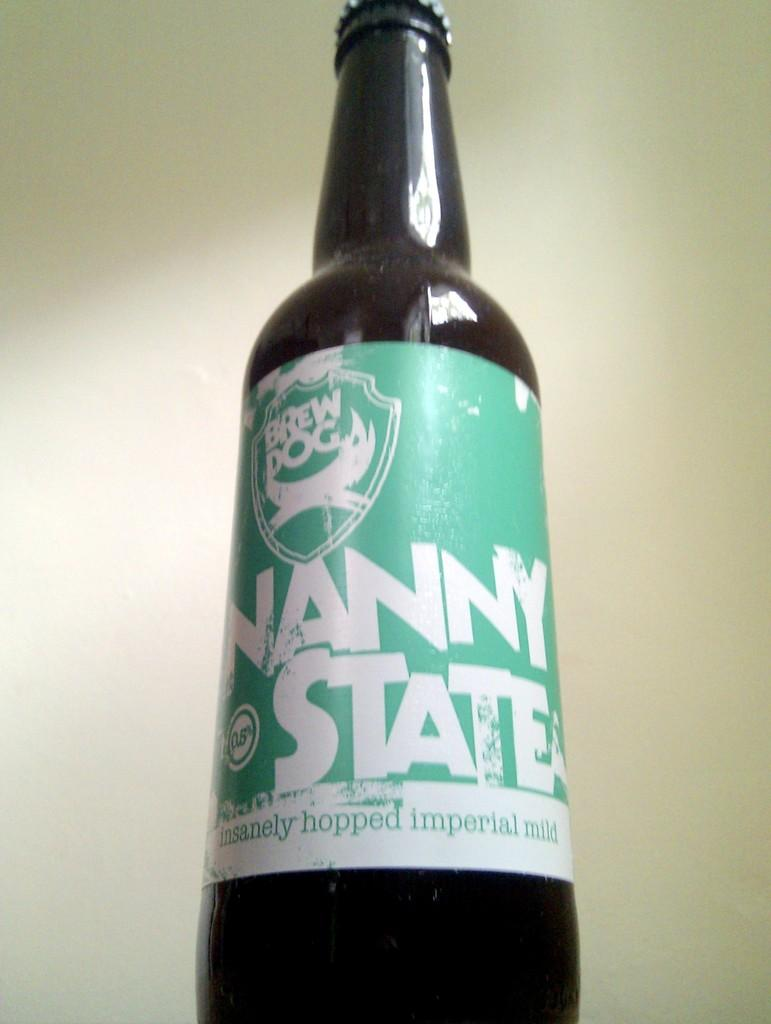<image>
Describe the image concisely. A closed bottle of Nanny state beer from brew dog. 